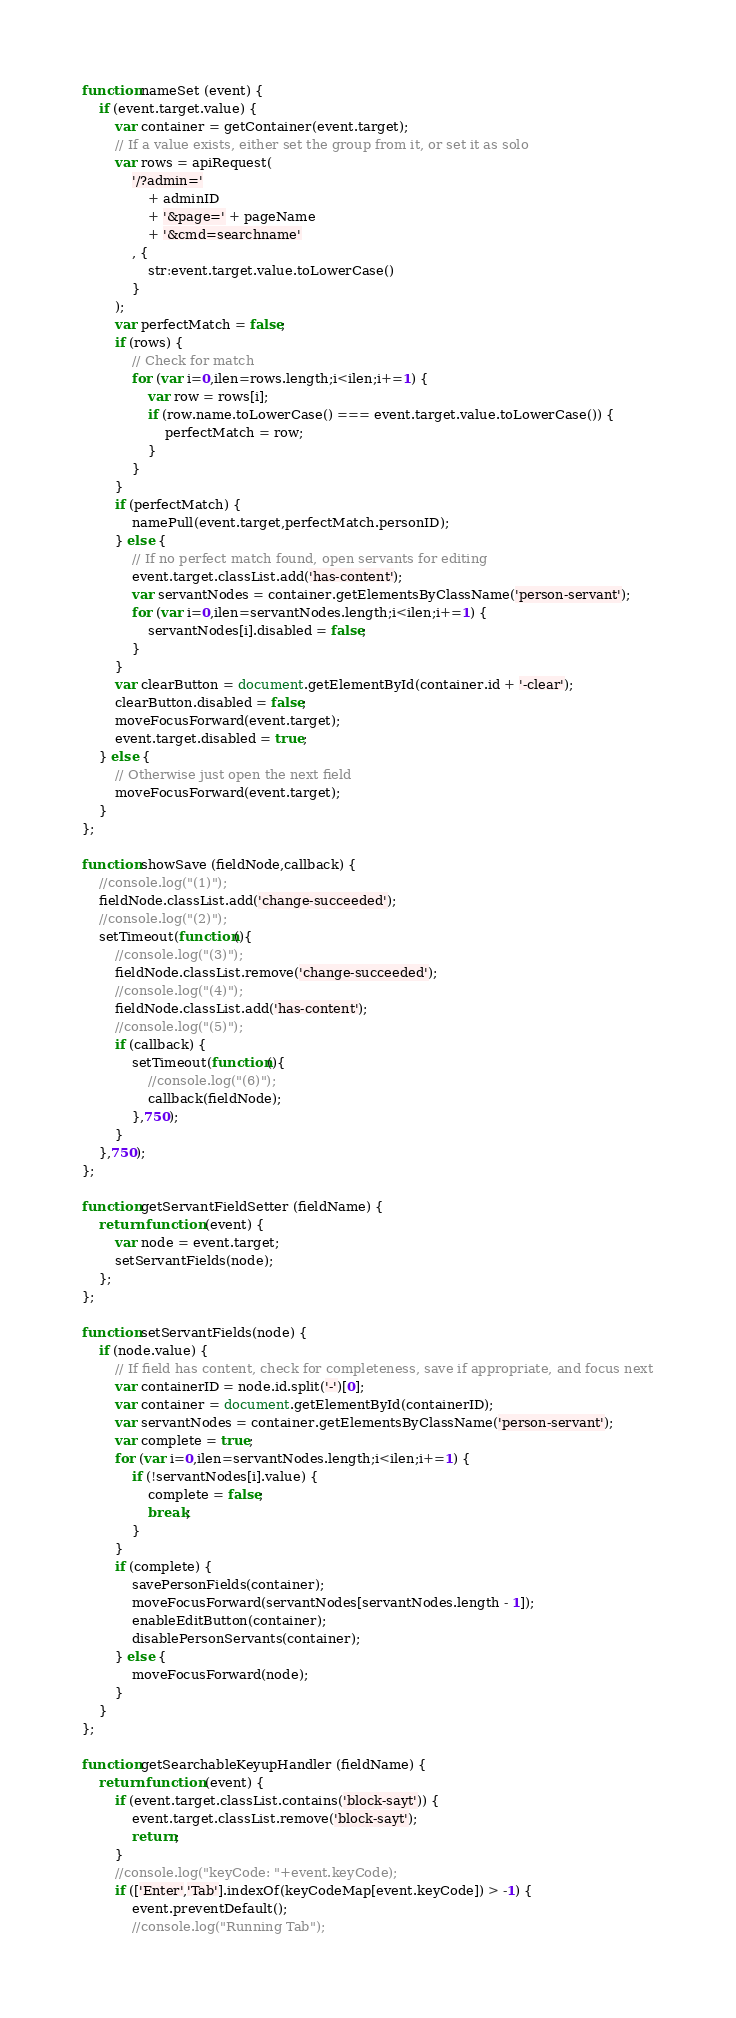<code> <loc_0><loc_0><loc_500><loc_500><_JavaScript_>function nameSet (event) {
    if (event.target.value) {
        var container = getContainer(event.target);
        // If a value exists, either set the group from it, or set it as solo
        var rows = apiRequest(
            '/?admin='
                + adminID
                + '&page=' + pageName
                + '&cmd=searchname'
            , {
                str:event.target.value.toLowerCase()
            }
        );
        var perfectMatch = false;
        if (rows) {
            // Check for match
            for (var i=0,ilen=rows.length;i<ilen;i+=1) {
                var row = rows[i];
                if (row.name.toLowerCase() === event.target.value.toLowerCase()) {
                    perfectMatch = row;
                }
            }
        }
        if (perfectMatch) {
            namePull(event.target,perfectMatch.personID);
        } else {
            // If no perfect match found, open servants for editing
            event.target.classList.add('has-content');
            var servantNodes = container.getElementsByClassName('person-servant');
            for (var i=0,ilen=servantNodes.length;i<ilen;i+=1) {
                servantNodes[i].disabled = false;
            }
        }
        var clearButton = document.getElementById(container.id + '-clear');
        clearButton.disabled = false;
        moveFocusForward(event.target);
        event.target.disabled = true;
    } else {
        // Otherwise just open the next field
        moveFocusForward(event.target);
    }
};

function showSave (fieldNode,callback) {
    //console.log("(1)");
    fieldNode.classList.add('change-succeeded');
    //console.log("(2)");
    setTimeout(function(){
        //console.log("(3)");
        fieldNode.classList.remove('change-succeeded');
        //console.log("(4)");
        fieldNode.classList.add('has-content');
        //console.log("(5)");
        if (callback) {
            setTimeout(function(){
                //console.log("(6)");
                callback(fieldNode);
            },750);
        }
    },750);
};

function getServantFieldSetter (fieldName) {
    return function (event) {
        var node = event.target;
        setServantFields(node);
    };
};

function setServantFields(node) {
    if (node.value) {
        // If field has content, check for completeness, save if appropriate, and focus next
        var containerID = node.id.split('-')[0];
        var container = document.getElementById(containerID);
        var servantNodes = container.getElementsByClassName('person-servant');
        var complete = true;
        for (var i=0,ilen=servantNodes.length;i<ilen;i+=1) {
            if (!servantNodes[i].value) {
                complete = false;
                break;
            }
        }
        if (complete) {
            savePersonFields(container);
            moveFocusForward(servantNodes[servantNodes.length - 1]);
            enableEditButton(container);
            disablePersonServants(container);
        } else {
            moveFocusForward(node);
        }
    }
};

function getSearchableKeyupHandler (fieldName) {
    return function (event) {
        if (event.target.classList.contains('block-sayt')) {
            event.target.classList.remove('block-sayt');
            return;
        }
        //console.log("keyCode: "+event.keyCode);
        if (['Enter','Tab'].indexOf(keyCodeMap[event.keyCode]) > -1) {
            event.preventDefault();
            //console.log("Running Tab");</code> 